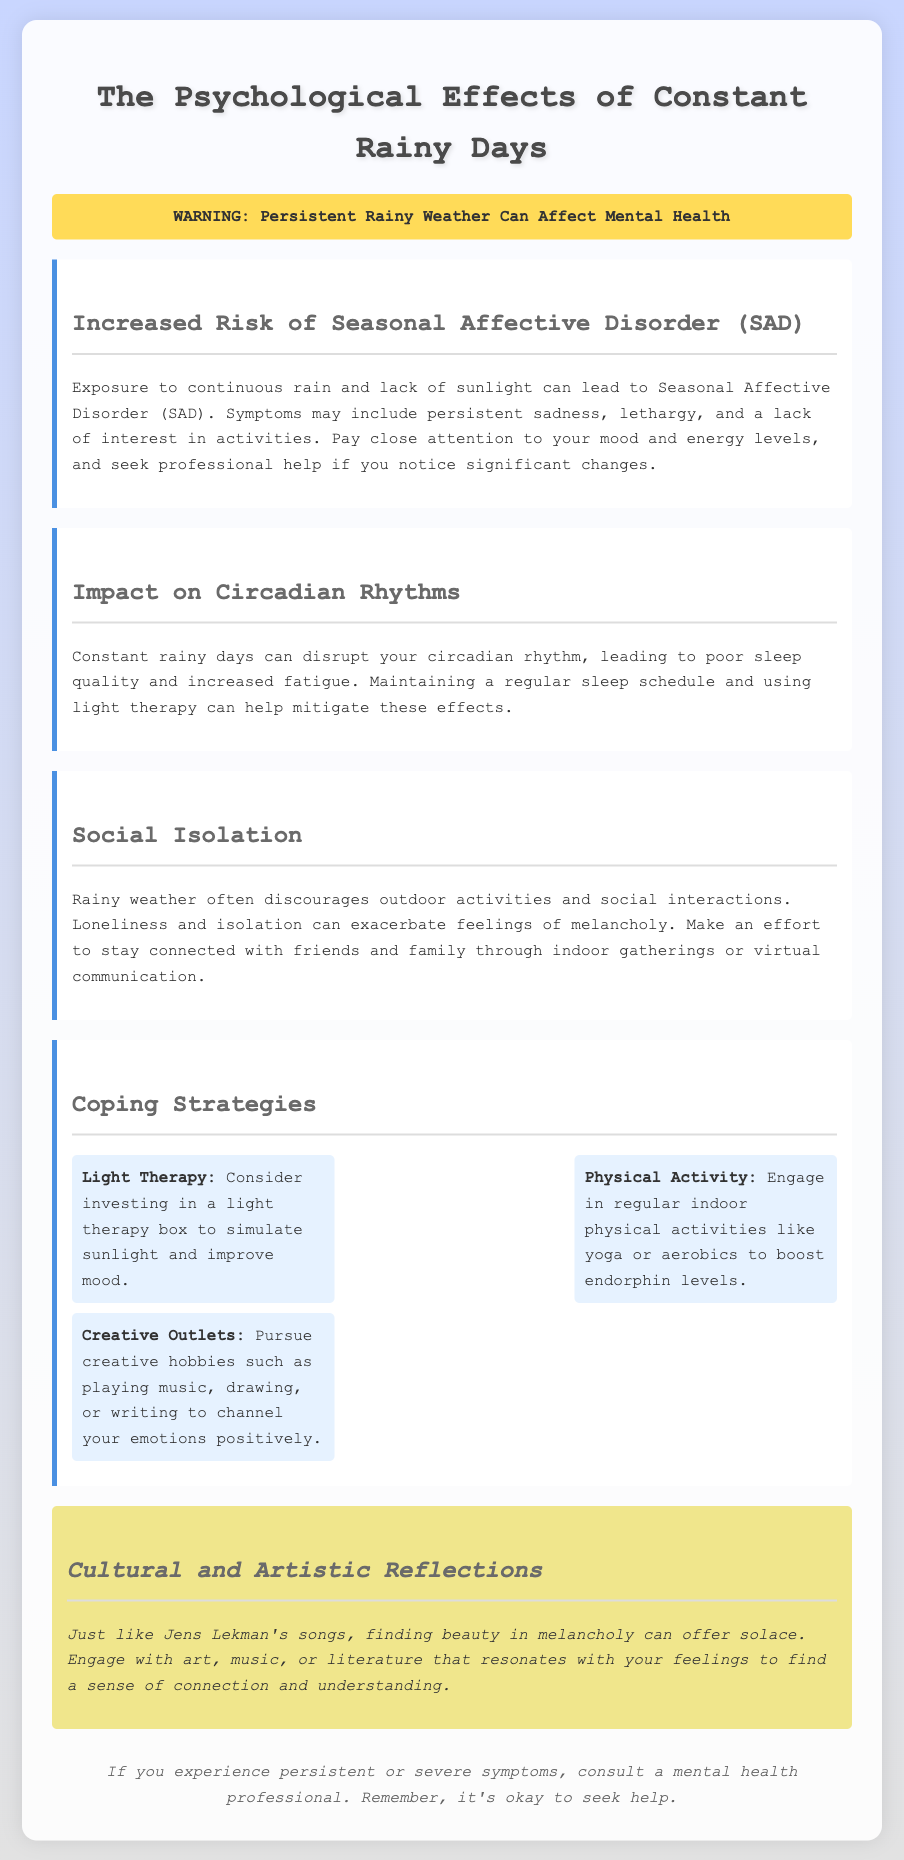What is the primary warning in the document? The document warns about the effects of persistent rainy weather on mental health.
Answer: Persistent Rainy Weather Can Affect Mental Health What disorder is mentioned as being related to constant rain? The document mentions Seasonal Affective Disorder (SAD) as being associated with rainy weather.
Answer: Seasonal Affective Disorder (SAD) What coping strategy involves simulating sunlight? The document suggests using a light therapy box as a coping strategy.
Answer: Light Therapy What can constant rainy days disrupt? Constant rainy days can disrupt circadian rhythms, rather than just affecting mood.
Answer: Circadian Rhythms How many coping strategies are listed? The document lists three specific coping strategies for managing melancholy induced by rain.
Answer: Three 